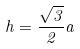<formula> <loc_0><loc_0><loc_500><loc_500>h = \frac { \sqrt { 3 } } { 2 } a</formula> 